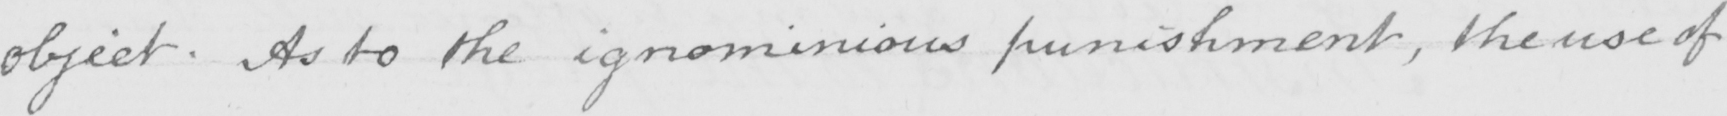Can you read and transcribe this handwriting? object . As to the ignominious punishment , the use of 